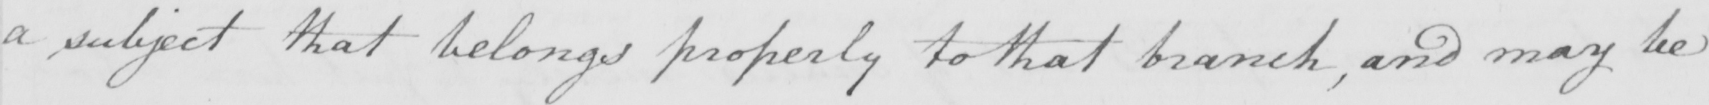What is written in this line of handwriting? a subject that belongs properly to that branch , and may be 